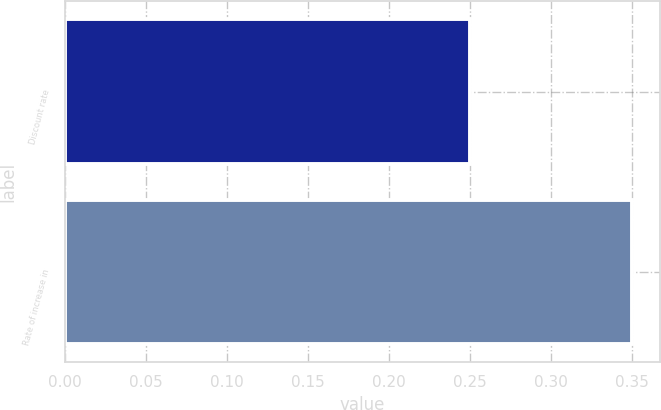<chart> <loc_0><loc_0><loc_500><loc_500><bar_chart><fcel>Discount rate<fcel>Rate of increase in<nl><fcel>0.25<fcel>0.35<nl></chart> 